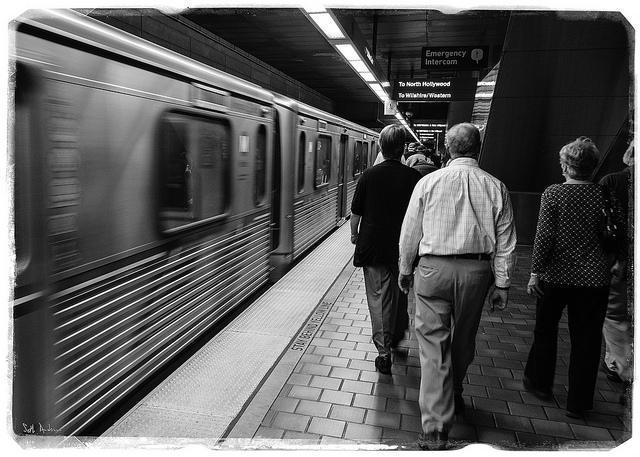What must be paid to ride this machine?
From the following set of four choices, select the accurate answer to respond to the question.
Options: Fee, tax, donation, fare. Fare. 